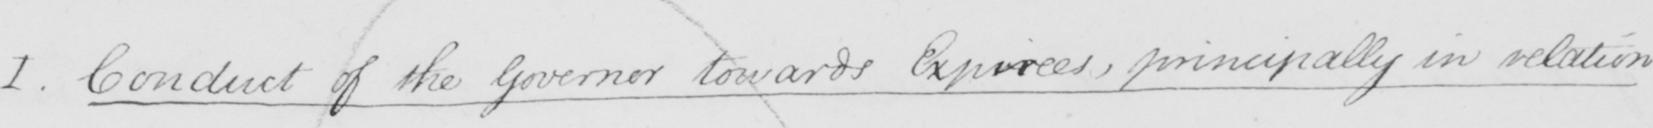Please transcribe the handwritten text in this image. I . Conduct of the Governor towards Expirees , principally in relation 